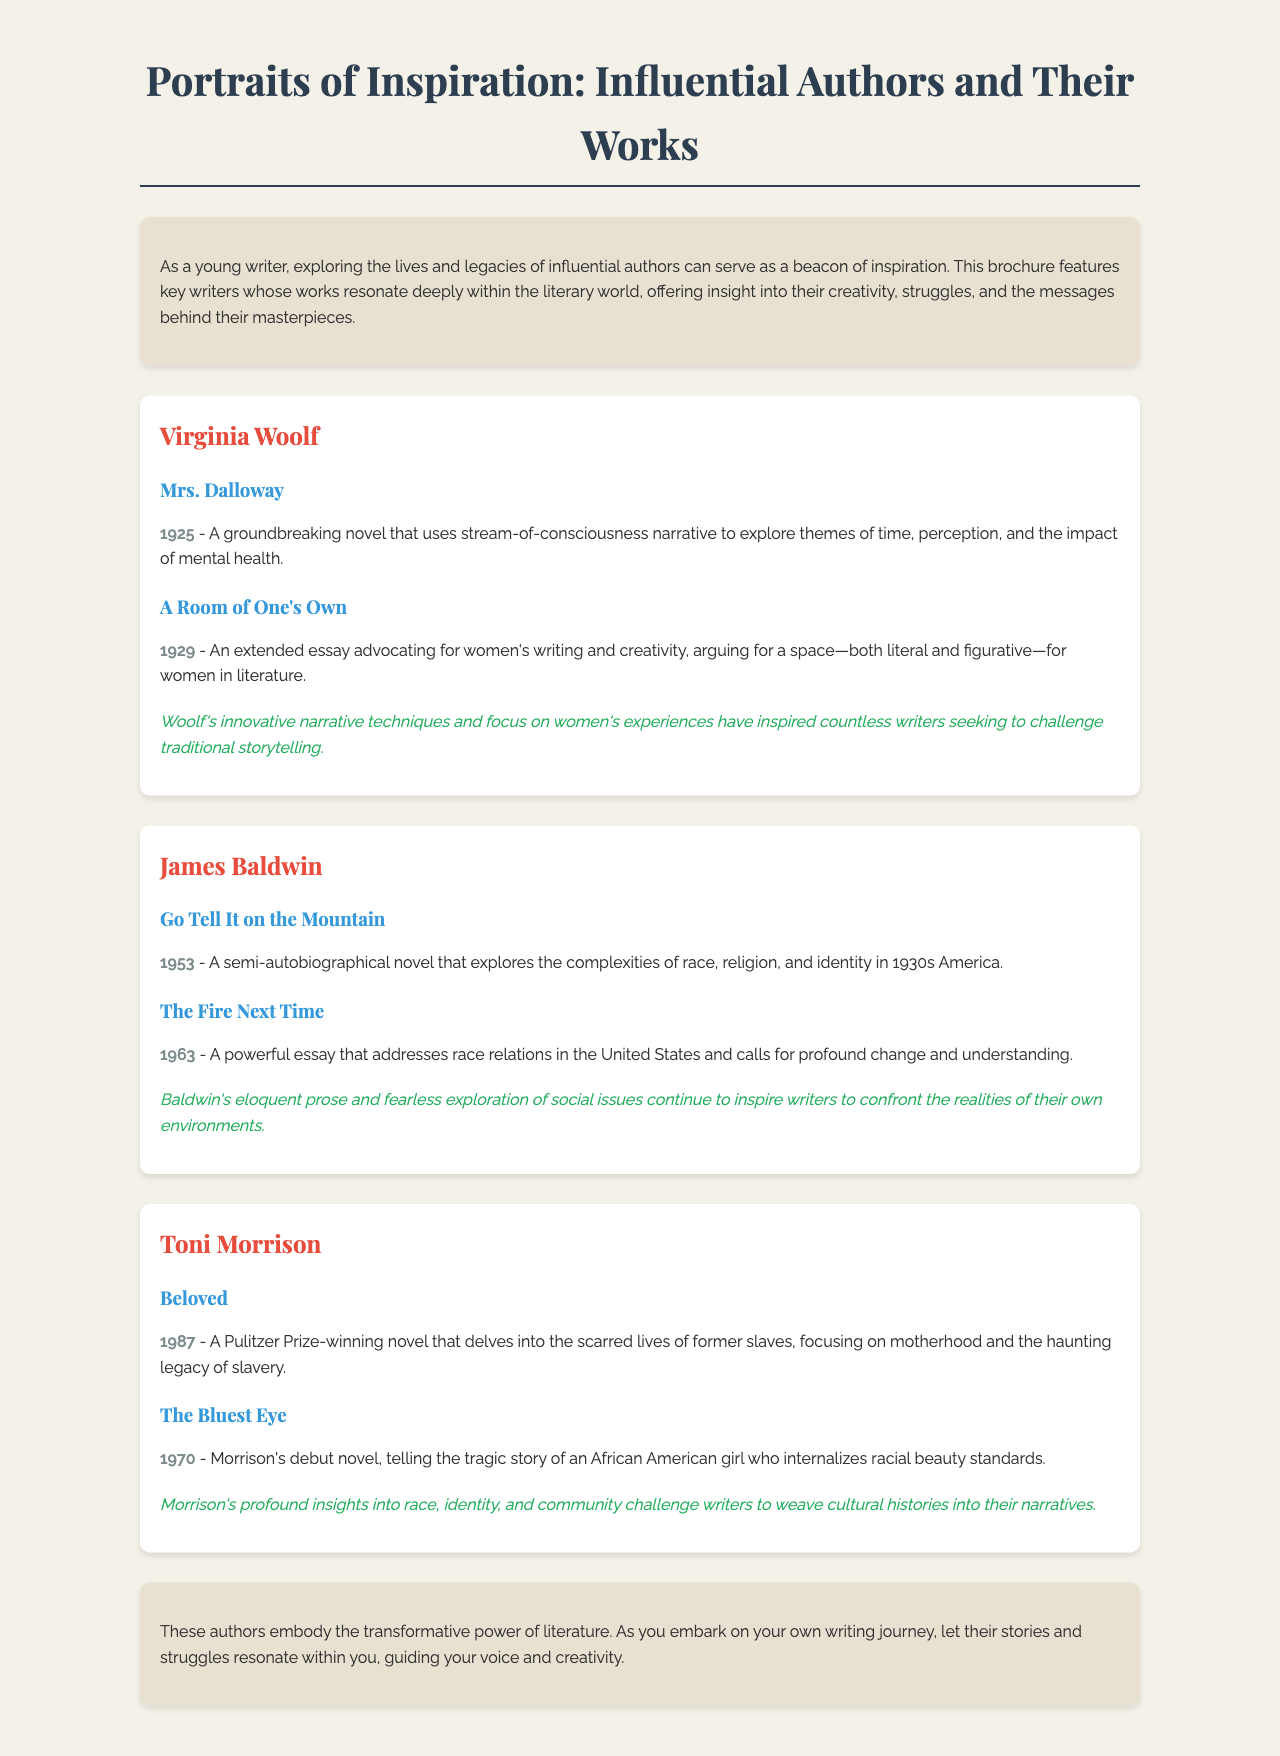What is the title of the brochure? The title of the brochure is presented prominently at the top.
Answer: Portraits of Inspiration: Influential Authors and Their Works Who is the author of "Mrs. Dalloway"? The section about Woolf clearly states her name associated with the work.
Answer: Virginia Woolf What year was "Beloved" published? The publication year is indicated next to the work in the document.
Answer: 1987 Which author wrote "Go Tell It on the Mountain"? The document attributes this work to Baldwin in his section.
Answer: James Baldwin What theme is explored in "A Room of One's Own"? The theme is included in the description of the work in the document.
Answer: Women's writing and creativity How many works by Toni Morrison are mentioned? The document lists her works, which can be counted.
Answer: Two What literary technique is Virginia Woolf noted for in "Mrs. Dalloway"? The description points out her notable narrative style used in this work.
Answer: Stream-of-consciousness narrative What is one influence of James Baldwin highlighted in the document? The influence of Baldwin is summarized in the conclusion of his section.
Answer: Eloquent prose and fearless exploration of social issues What is the structure of the brochure? The brochure is organized into sections that introduce authors and their works.
Answer: Author profiles and works 